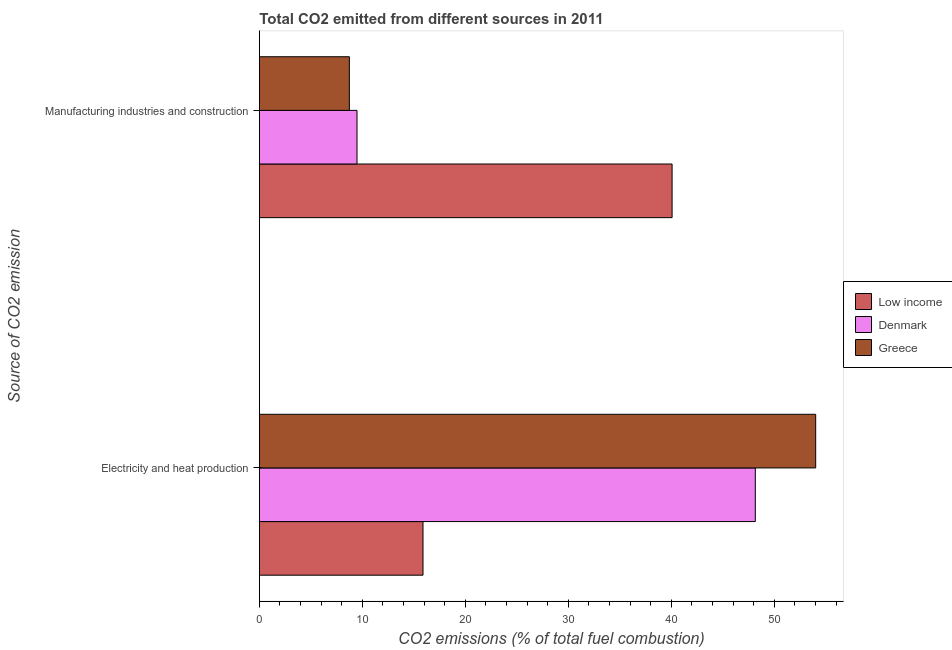How many different coloured bars are there?
Provide a short and direct response. 3. Are the number of bars on each tick of the Y-axis equal?
Offer a terse response. Yes. How many bars are there on the 1st tick from the top?
Provide a short and direct response. 3. How many bars are there on the 1st tick from the bottom?
Your answer should be very brief. 3. What is the label of the 2nd group of bars from the top?
Offer a very short reply. Electricity and heat production. What is the co2 emissions due to manufacturing industries in Low income?
Your answer should be compact. 40.08. Across all countries, what is the maximum co2 emissions due to manufacturing industries?
Your answer should be compact. 40.08. Across all countries, what is the minimum co2 emissions due to electricity and heat production?
Your response must be concise. 15.89. In which country was the co2 emissions due to manufacturing industries minimum?
Offer a terse response. Greece. What is the total co2 emissions due to electricity and heat production in the graph?
Your answer should be very brief. 118.07. What is the difference between the co2 emissions due to electricity and heat production in Greece and that in Denmark?
Offer a very short reply. 5.86. What is the difference between the co2 emissions due to manufacturing industries in Denmark and the co2 emissions due to electricity and heat production in Greece?
Offer a very short reply. -44.54. What is the average co2 emissions due to electricity and heat production per country?
Make the answer very short. 39.36. What is the difference between the co2 emissions due to electricity and heat production and co2 emissions due to manufacturing industries in Greece?
Your response must be concise. 45.28. What is the ratio of the co2 emissions due to electricity and heat production in Denmark to that in Greece?
Your answer should be very brief. 0.89. Is the co2 emissions due to manufacturing industries in Greece less than that in Denmark?
Keep it short and to the point. Yes. Are the values on the major ticks of X-axis written in scientific E-notation?
Provide a short and direct response. No. Does the graph contain any zero values?
Give a very brief answer. No. Does the graph contain grids?
Your response must be concise. No. What is the title of the graph?
Your answer should be compact. Total CO2 emitted from different sources in 2011. What is the label or title of the X-axis?
Your response must be concise. CO2 emissions (% of total fuel combustion). What is the label or title of the Y-axis?
Offer a very short reply. Source of CO2 emission. What is the CO2 emissions (% of total fuel combustion) of Low income in Electricity and heat production?
Your answer should be very brief. 15.89. What is the CO2 emissions (% of total fuel combustion) of Denmark in Electricity and heat production?
Provide a succinct answer. 48.16. What is the CO2 emissions (% of total fuel combustion) in Greece in Electricity and heat production?
Your answer should be very brief. 54.02. What is the CO2 emissions (% of total fuel combustion) in Low income in Manufacturing industries and construction?
Ensure brevity in your answer.  40.08. What is the CO2 emissions (% of total fuel combustion) of Denmark in Manufacturing industries and construction?
Give a very brief answer. 9.48. What is the CO2 emissions (% of total fuel combustion) in Greece in Manufacturing industries and construction?
Give a very brief answer. 8.74. Across all Source of CO2 emission, what is the maximum CO2 emissions (% of total fuel combustion) in Low income?
Your response must be concise. 40.08. Across all Source of CO2 emission, what is the maximum CO2 emissions (% of total fuel combustion) of Denmark?
Offer a very short reply. 48.16. Across all Source of CO2 emission, what is the maximum CO2 emissions (% of total fuel combustion) of Greece?
Your response must be concise. 54.02. Across all Source of CO2 emission, what is the minimum CO2 emissions (% of total fuel combustion) in Low income?
Ensure brevity in your answer.  15.89. Across all Source of CO2 emission, what is the minimum CO2 emissions (% of total fuel combustion) of Denmark?
Your response must be concise. 9.48. Across all Source of CO2 emission, what is the minimum CO2 emissions (% of total fuel combustion) of Greece?
Keep it short and to the point. 8.74. What is the total CO2 emissions (% of total fuel combustion) of Low income in the graph?
Provide a succinct answer. 55.97. What is the total CO2 emissions (% of total fuel combustion) in Denmark in the graph?
Provide a short and direct response. 57.64. What is the total CO2 emissions (% of total fuel combustion) of Greece in the graph?
Your response must be concise. 62.76. What is the difference between the CO2 emissions (% of total fuel combustion) in Low income in Electricity and heat production and that in Manufacturing industries and construction?
Your answer should be compact. -24.19. What is the difference between the CO2 emissions (% of total fuel combustion) of Denmark in Electricity and heat production and that in Manufacturing industries and construction?
Provide a succinct answer. 38.67. What is the difference between the CO2 emissions (% of total fuel combustion) of Greece in Electricity and heat production and that in Manufacturing industries and construction?
Your response must be concise. 45.28. What is the difference between the CO2 emissions (% of total fuel combustion) of Low income in Electricity and heat production and the CO2 emissions (% of total fuel combustion) of Denmark in Manufacturing industries and construction?
Keep it short and to the point. 6.41. What is the difference between the CO2 emissions (% of total fuel combustion) of Low income in Electricity and heat production and the CO2 emissions (% of total fuel combustion) of Greece in Manufacturing industries and construction?
Keep it short and to the point. 7.15. What is the difference between the CO2 emissions (% of total fuel combustion) of Denmark in Electricity and heat production and the CO2 emissions (% of total fuel combustion) of Greece in Manufacturing industries and construction?
Your answer should be compact. 39.42. What is the average CO2 emissions (% of total fuel combustion) of Low income per Source of CO2 emission?
Provide a succinct answer. 27.98. What is the average CO2 emissions (% of total fuel combustion) of Denmark per Source of CO2 emission?
Offer a terse response. 28.82. What is the average CO2 emissions (% of total fuel combustion) in Greece per Source of CO2 emission?
Your response must be concise. 31.38. What is the difference between the CO2 emissions (% of total fuel combustion) of Low income and CO2 emissions (% of total fuel combustion) of Denmark in Electricity and heat production?
Your answer should be compact. -32.27. What is the difference between the CO2 emissions (% of total fuel combustion) of Low income and CO2 emissions (% of total fuel combustion) of Greece in Electricity and heat production?
Keep it short and to the point. -38.13. What is the difference between the CO2 emissions (% of total fuel combustion) of Denmark and CO2 emissions (% of total fuel combustion) of Greece in Electricity and heat production?
Your response must be concise. -5.86. What is the difference between the CO2 emissions (% of total fuel combustion) of Low income and CO2 emissions (% of total fuel combustion) of Denmark in Manufacturing industries and construction?
Provide a short and direct response. 30.59. What is the difference between the CO2 emissions (% of total fuel combustion) in Low income and CO2 emissions (% of total fuel combustion) in Greece in Manufacturing industries and construction?
Offer a terse response. 31.34. What is the difference between the CO2 emissions (% of total fuel combustion) in Denmark and CO2 emissions (% of total fuel combustion) in Greece in Manufacturing industries and construction?
Make the answer very short. 0.74. What is the ratio of the CO2 emissions (% of total fuel combustion) in Low income in Electricity and heat production to that in Manufacturing industries and construction?
Provide a succinct answer. 0.4. What is the ratio of the CO2 emissions (% of total fuel combustion) of Denmark in Electricity and heat production to that in Manufacturing industries and construction?
Ensure brevity in your answer.  5.08. What is the ratio of the CO2 emissions (% of total fuel combustion) of Greece in Electricity and heat production to that in Manufacturing industries and construction?
Offer a very short reply. 6.18. What is the difference between the highest and the second highest CO2 emissions (% of total fuel combustion) of Low income?
Your answer should be very brief. 24.19. What is the difference between the highest and the second highest CO2 emissions (% of total fuel combustion) of Denmark?
Offer a terse response. 38.67. What is the difference between the highest and the second highest CO2 emissions (% of total fuel combustion) of Greece?
Keep it short and to the point. 45.28. What is the difference between the highest and the lowest CO2 emissions (% of total fuel combustion) of Low income?
Your answer should be very brief. 24.19. What is the difference between the highest and the lowest CO2 emissions (% of total fuel combustion) in Denmark?
Ensure brevity in your answer.  38.67. What is the difference between the highest and the lowest CO2 emissions (% of total fuel combustion) in Greece?
Keep it short and to the point. 45.28. 